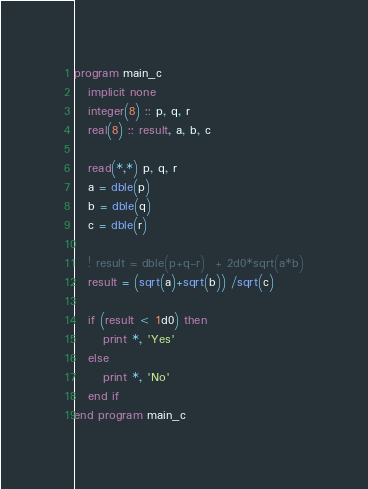Convert code to text. <code><loc_0><loc_0><loc_500><loc_500><_FORTRAN_>program main_c
   implicit none
   integer(8) :: p, q, r
   real(8) :: result, a, b, c

   read(*,*) p, q, r
   a = dble(p)
   b = dble(q)
   c = dble(r)

   ! result = dble(p+q-r)  + 2d0*sqrt(a*b)
   result = (sqrt(a)+sqrt(b)) /sqrt(c)

   if (result < 1d0) then
      print *, 'Yes'
   else
      print *, 'No'
   end if
end program main_c
</code> 